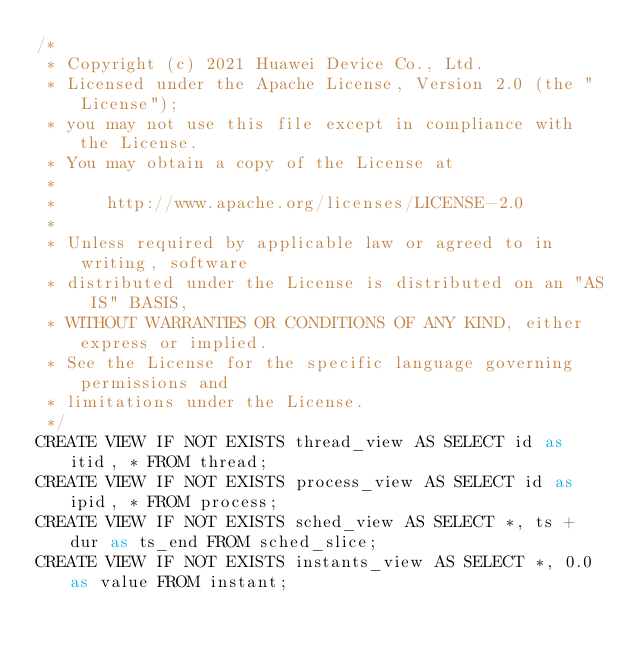Convert code to text. <code><loc_0><loc_0><loc_500><loc_500><_SQL_>/*
 * Copyright (c) 2021 Huawei Device Co., Ltd.
 * Licensed under the Apache License, Version 2.0 (the "License");
 * you may not use this file except in compliance with the License.
 * You may obtain a copy of the License at
 *
 *     http://www.apache.org/licenses/LICENSE-2.0
 *
 * Unless required by applicable law or agreed to in writing, software
 * distributed under the License is distributed on an "AS IS" BASIS,
 * WITHOUT WARRANTIES OR CONDITIONS OF ANY KIND, either express or implied.
 * See the License for the specific language governing permissions and
 * limitations under the License.
 */
CREATE VIEW IF NOT EXISTS thread_view AS SELECT id as itid, * FROM thread;
CREATE VIEW IF NOT EXISTS process_view AS SELECT id as ipid, * FROM process;
CREATE VIEW IF NOT EXISTS sched_view AS SELECT *, ts + dur as ts_end FROM sched_slice;
CREATE VIEW IF NOT EXISTS instants_view AS SELECT *, 0.0 as value FROM instant;</code> 